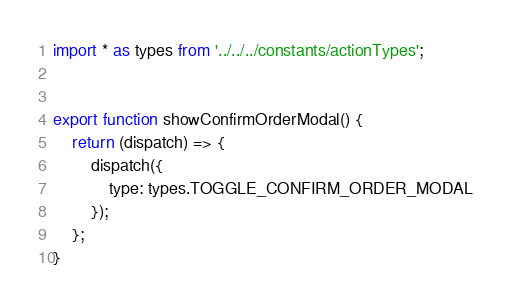<code> <loc_0><loc_0><loc_500><loc_500><_JavaScript_>import * as types from '../../../constants/actionTypes';


export function showConfirmOrderModal() {
    return (dispatch) => {
        dispatch({
            type: types.TOGGLE_CONFIRM_ORDER_MODAL
        });
    };
}

</code> 